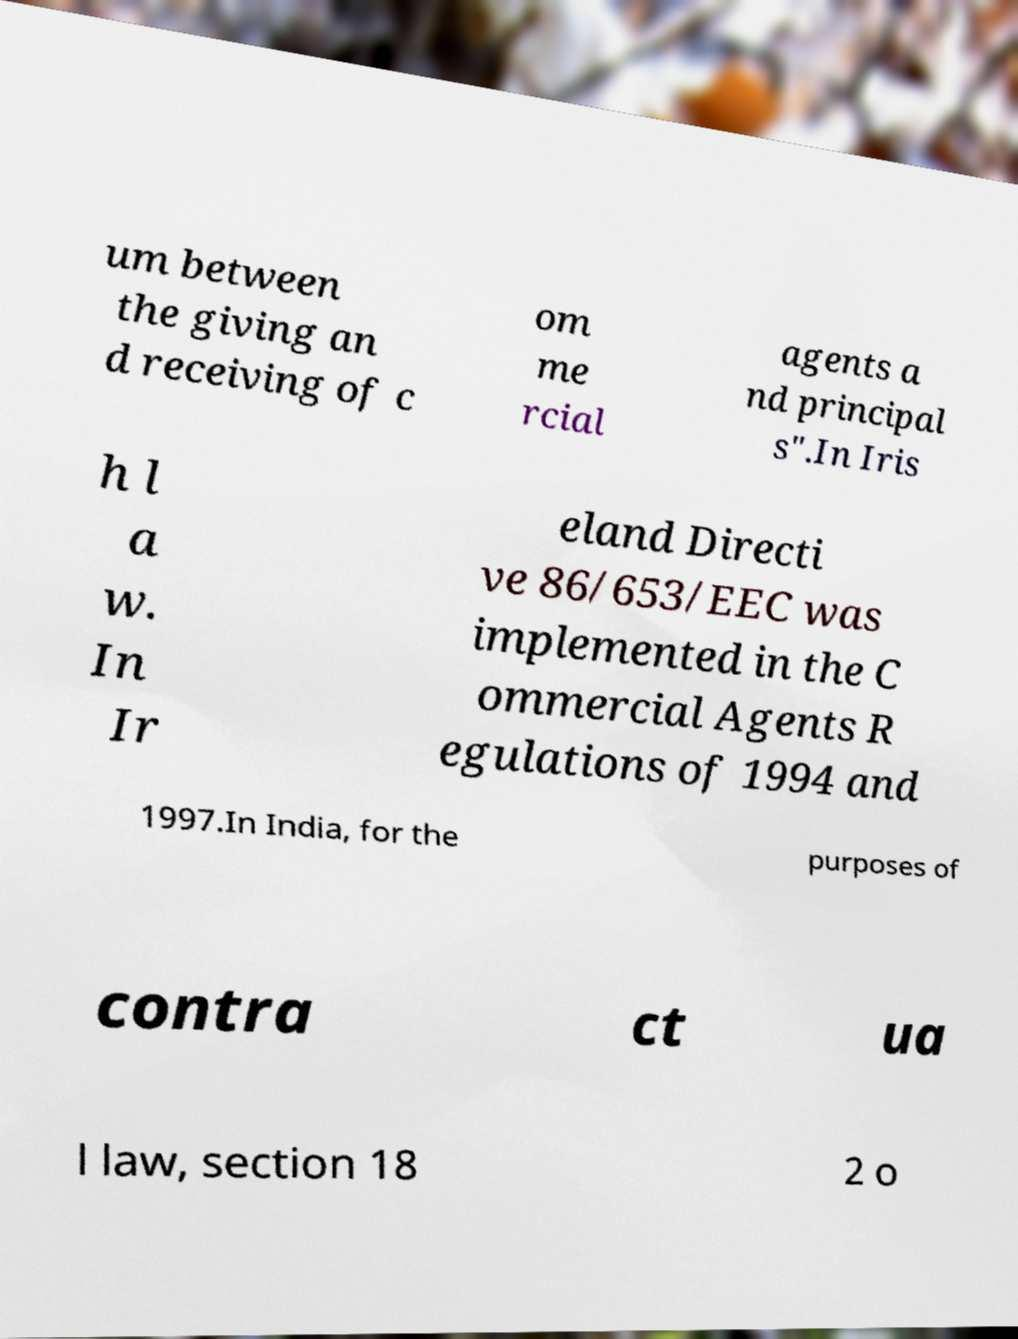Please read and relay the text visible in this image. What does it say? um between the giving an d receiving of c om me rcial agents a nd principal s".In Iris h l a w. In Ir eland Directi ve 86/653/EEC was implemented in the C ommercial Agents R egulations of 1994 and 1997.In India, for the purposes of contra ct ua l law, section 18 2 o 